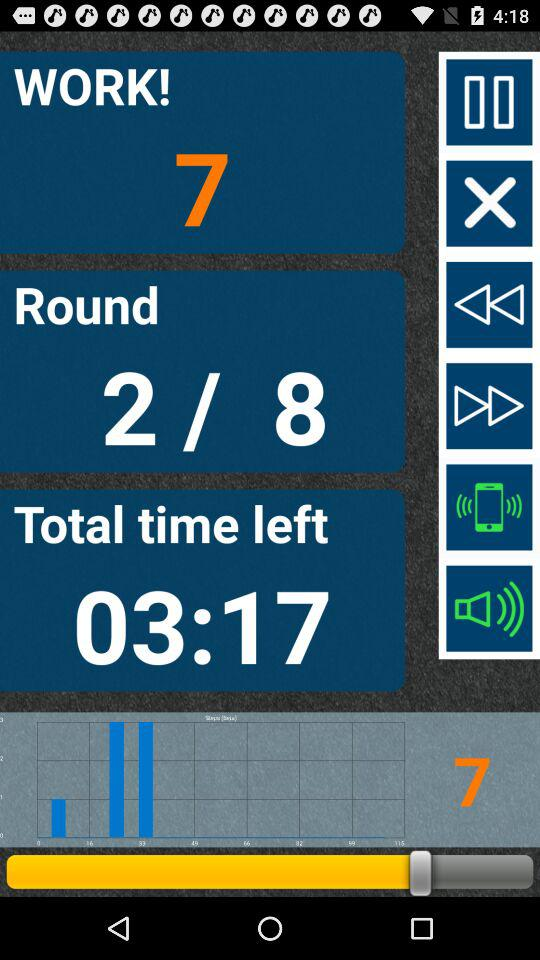How much is the total work? The total work is 7. 